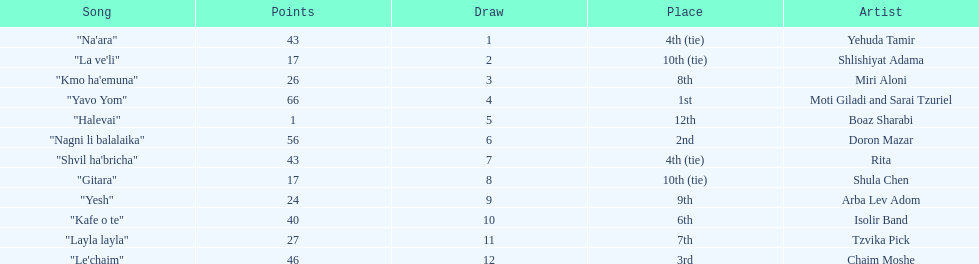What song earned the most points? "Yavo Yom". 